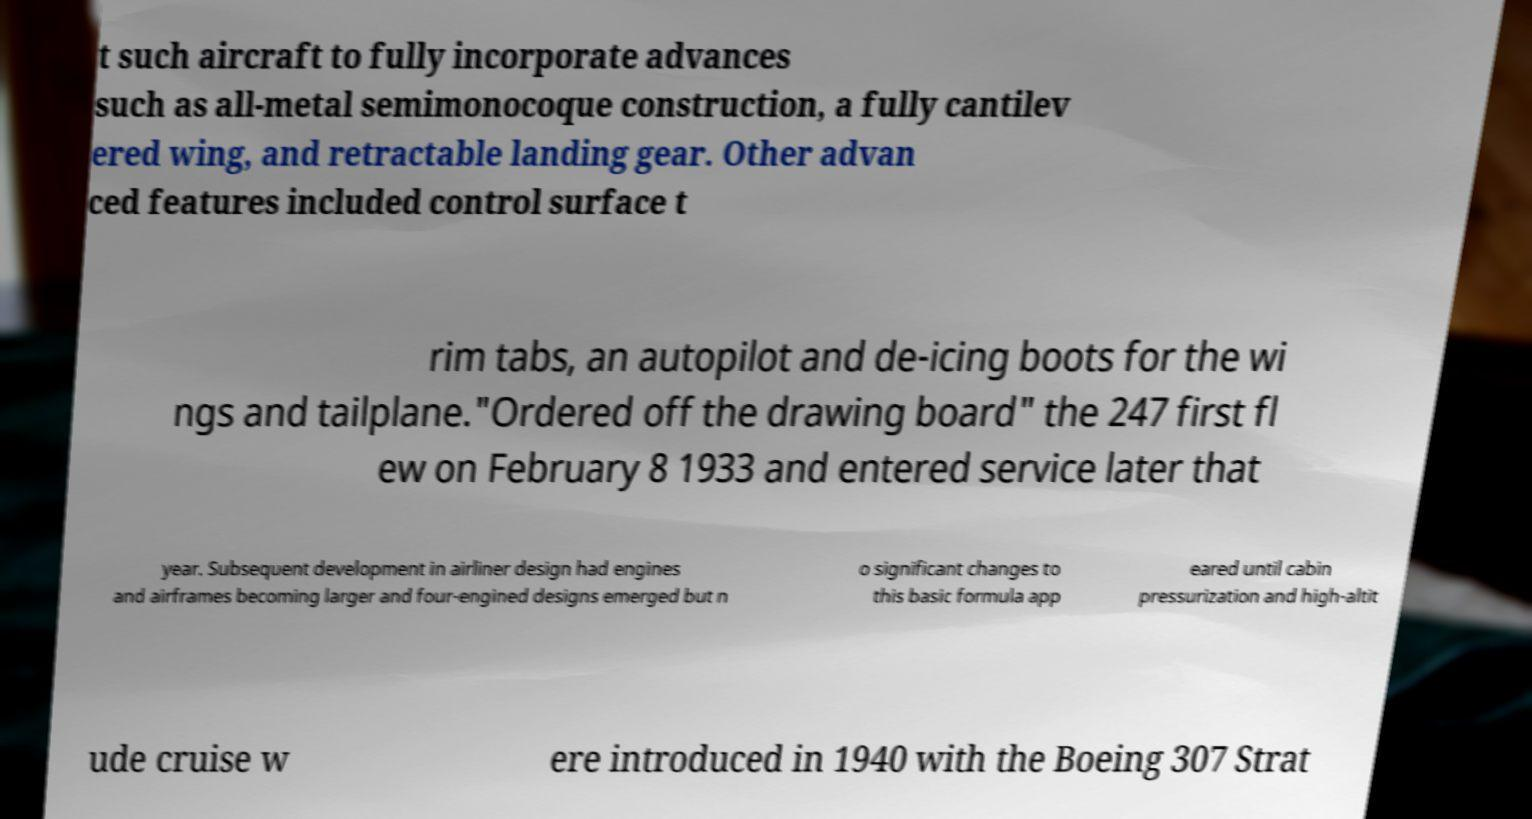Please identify and transcribe the text found in this image. t such aircraft to fully incorporate advances such as all-metal semimonocoque construction, a fully cantilev ered wing, and retractable landing gear. Other advan ced features included control surface t rim tabs, an autopilot and de-icing boots for the wi ngs and tailplane."Ordered off the drawing board" the 247 first fl ew on February 8 1933 and entered service later that year. Subsequent development in airliner design had engines and airframes becoming larger and four-engined designs emerged but n o significant changes to this basic formula app eared until cabin pressurization and high-altit ude cruise w ere introduced in 1940 with the Boeing 307 Strat 